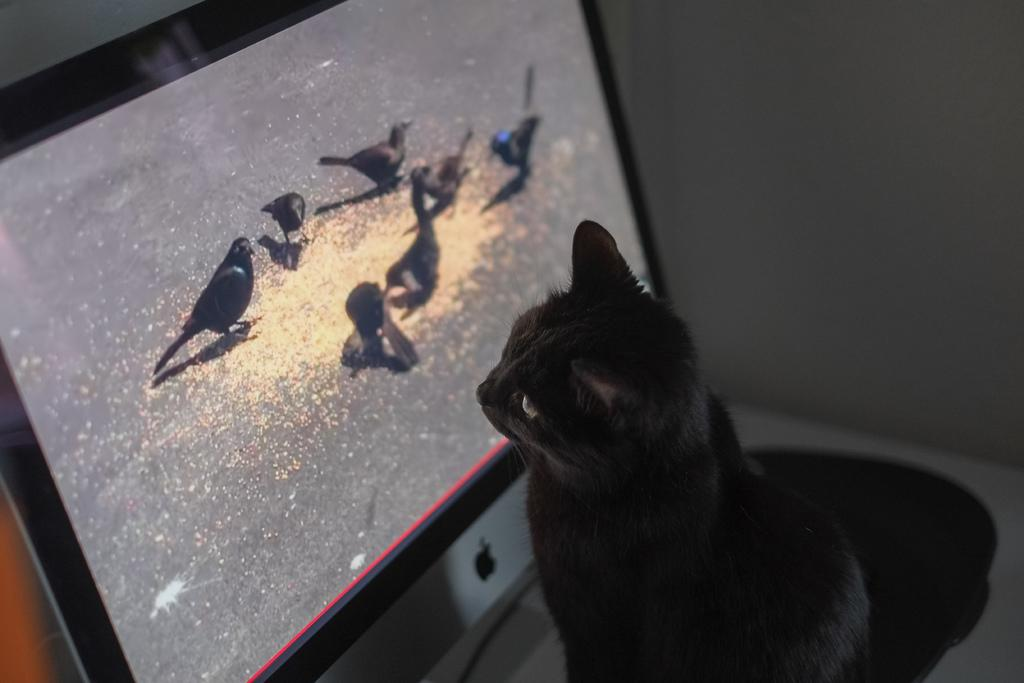What animal is sitting on the table in the image? There is a cat sitting on the table in the image. What is in front of the cat on the table? There is a T.V. with a screen in front of the cat. What can be seen on the T.V. screen? Birds and food items are visible on the T.V. screen. What type of scarecrow is standing next to the cat in the image? There is no scarecrow present in the image; it features a cat sitting on a table with a T.V. in front of it. Is the cat playing a record on the T.V. in the image? There is no record present in the image, and the cat is not interacting with the T.V. in any way. 